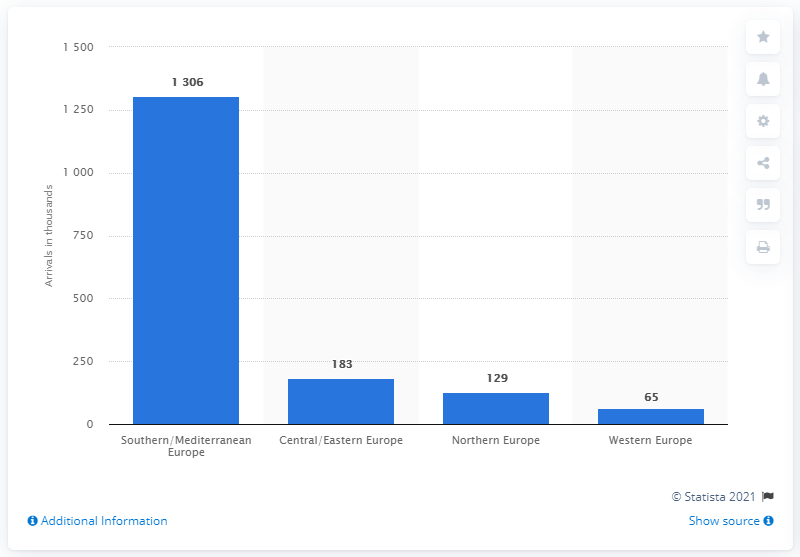List a handful of essential elements in this visual. In 2019, the southern/mediterranean region of Europe was the most visited by Argentinian tourists. 